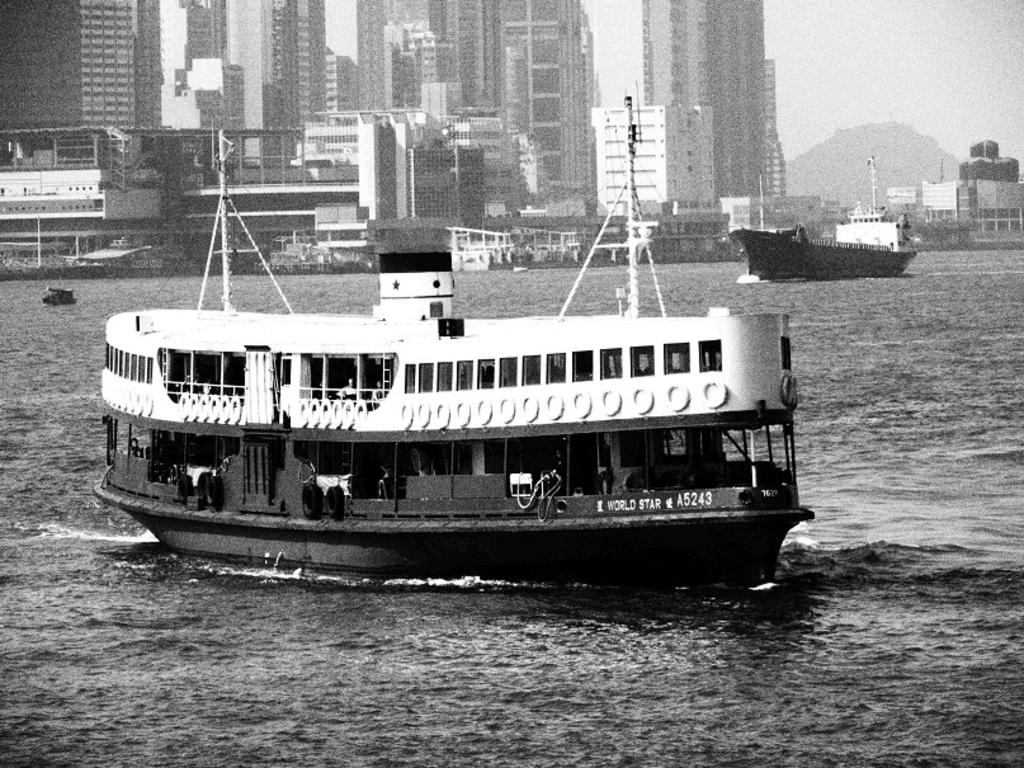What is the color scheme of the image? The image is black and white. What can be seen on the river in the image? There are ships on a river in the image. What type of structures are visible in the background? There are buildings in the background of the image. What natural feature can be seen in the background? There is a mountain in the background of the image. What type of sock is hanging on the rod in the image? There is no sock or rod present in the image; it features ships on a river with buildings and a mountain in the background. 